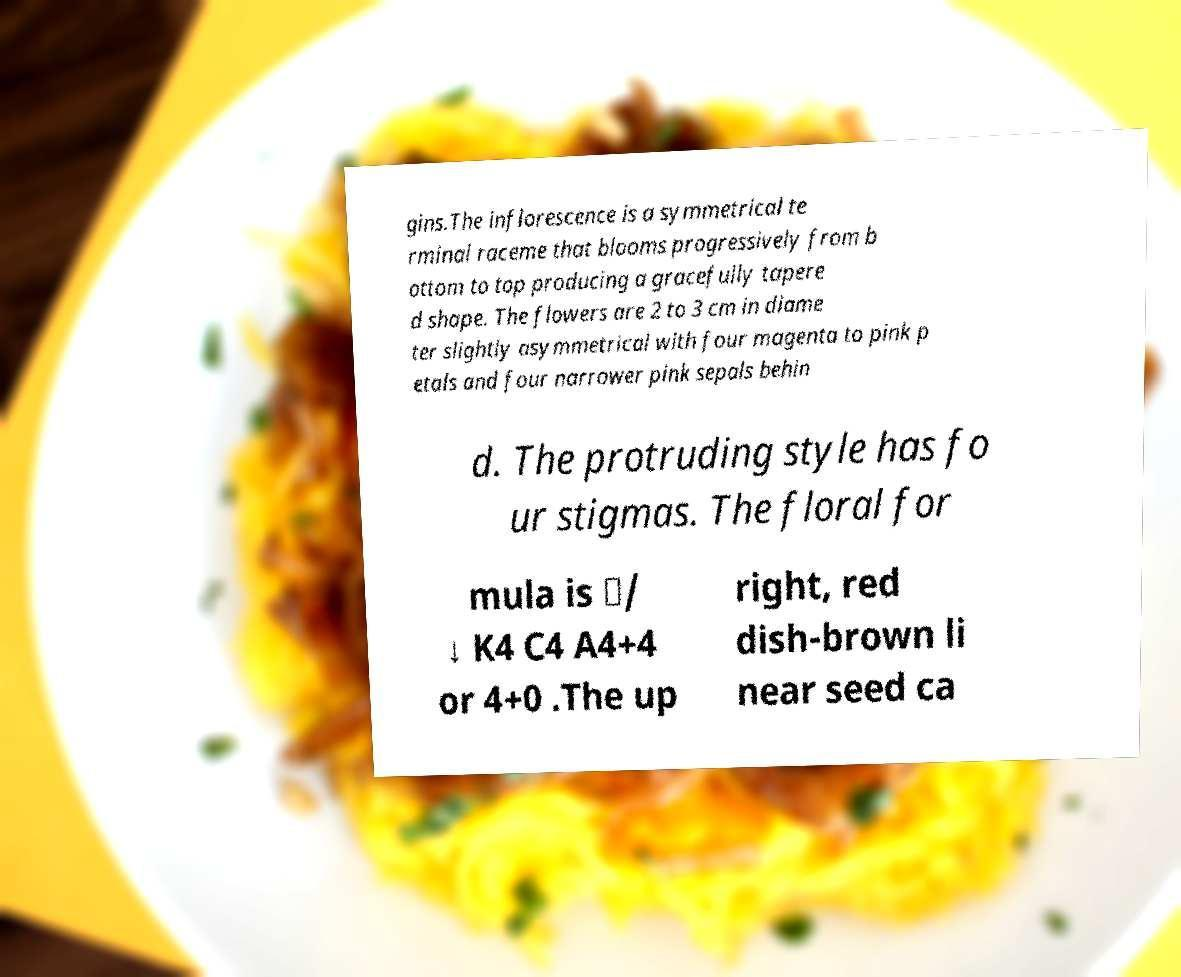Please read and relay the text visible in this image. What does it say? gins.The inflorescence is a symmetrical te rminal raceme that blooms progressively from b ottom to top producing a gracefully tapere d shape. The flowers are 2 to 3 cm in diame ter slightly asymmetrical with four magenta to pink p etals and four narrower pink sepals behin d. The protruding style has fo ur stigmas. The floral for mula is ✶/ ↓ K4 C4 A4+4 or 4+0 .The up right, red dish-brown li near seed ca 